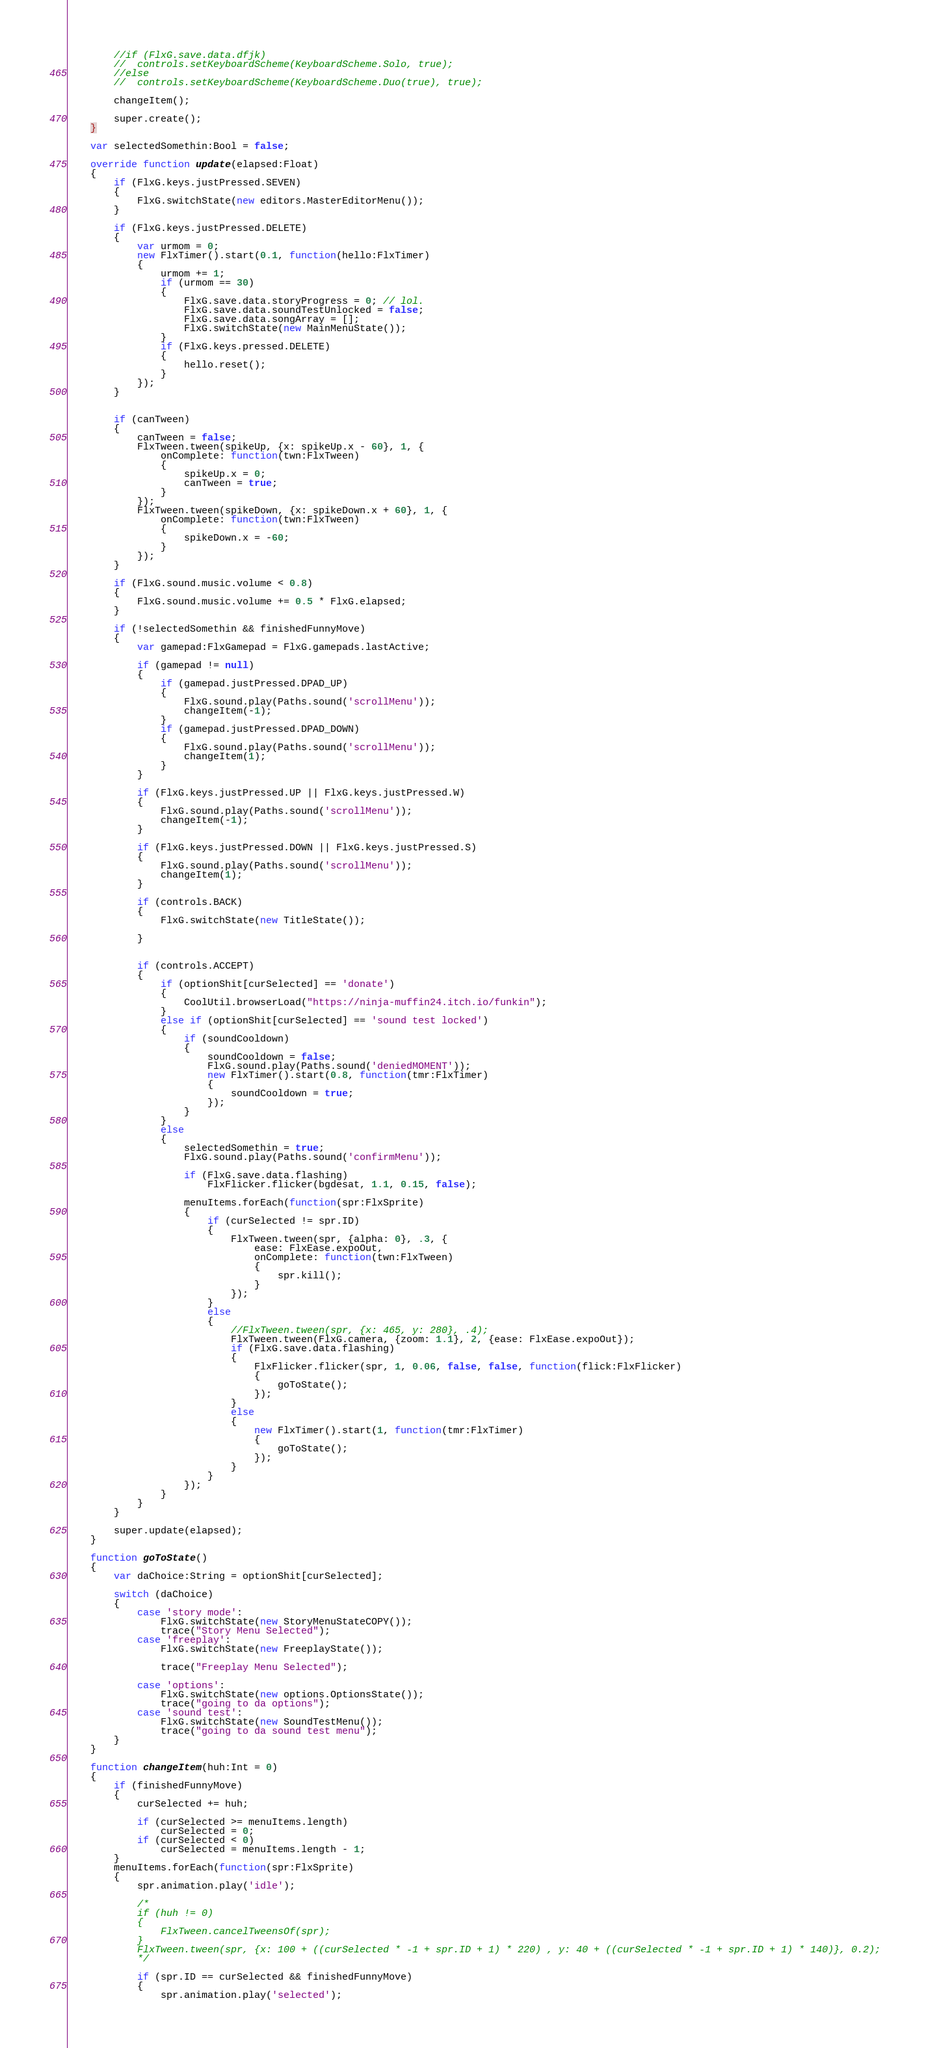Convert code to text. <code><loc_0><loc_0><loc_500><loc_500><_Haxe_>
		//if (FlxG.save.data.dfjk)
		//	controls.setKeyboardScheme(KeyboardScheme.Solo, true);
		//else
		//	controls.setKeyboardScheme(KeyboardScheme.Duo(true), true);

		changeItem();

		super.create();
	}

	var selectedSomethin:Bool = false;

	override function update(elapsed:Float)
	{
		if (FlxG.keys.justPressed.SEVEN)
		{
			FlxG.switchState(new editors.MasterEditorMenu());
		}

		if (FlxG.keys.justPressed.DELETE)
		{
			var urmom = 0;
			new FlxTimer().start(0.1, function(hello:FlxTimer)
			{
				urmom += 1;
				if (urmom == 30)
				{
					FlxG.save.data.storyProgress = 0; // lol.
					FlxG.save.data.soundTestUnlocked = false;
					FlxG.save.data.songArray = [];
					FlxG.switchState(new MainMenuState());
				}
				if (FlxG.keys.pressed.DELETE)
				{
					hello.reset();
				}
			});
		}


		if (canTween)
		{
			canTween = false;
			FlxTween.tween(spikeUp, {x: spikeUp.x - 60}, 1, {
				onComplete: function(twn:FlxTween)
				{
					spikeUp.x = 0;
					canTween = true;
				}
			});
			FlxTween.tween(spikeDown, {x: spikeDown.x + 60}, 1, {
				onComplete: function(twn:FlxTween)
				{
					spikeDown.x = -60;
				}
			});
		}

		if (FlxG.sound.music.volume < 0.8)
		{
			FlxG.sound.music.volume += 0.5 * FlxG.elapsed;
		}

		if (!selectedSomethin && finishedFunnyMove)
		{
			var gamepad:FlxGamepad = FlxG.gamepads.lastActive;

			if (gamepad != null)
			{
				if (gamepad.justPressed.DPAD_UP)
				{
					FlxG.sound.play(Paths.sound('scrollMenu'));
					changeItem(-1);
				}
				if (gamepad.justPressed.DPAD_DOWN)
				{
					FlxG.sound.play(Paths.sound('scrollMenu'));
					changeItem(1);
				}
			}

			if (FlxG.keys.justPressed.UP || FlxG.keys.justPressed.W)
			{
				FlxG.sound.play(Paths.sound('scrollMenu'));
				changeItem(-1);
			}

			if (FlxG.keys.justPressed.DOWN || FlxG.keys.justPressed.S)
			{
				FlxG.sound.play(Paths.sound('scrollMenu'));
				changeItem(1);
			}

			if (controls.BACK)
			{
				FlxG.switchState(new TitleState());

			}


			if (controls.ACCEPT)
			{
				if (optionShit[curSelected] == 'donate')
				{
					CoolUtil.browserLoad("https://ninja-muffin24.itch.io/funkin");
				}
				else if (optionShit[curSelected] == 'sound test locked')
				{
					if (soundCooldown)
					{
						soundCooldown = false;
						FlxG.sound.play(Paths.sound('deniedMOMENT'));
						new FlxTimer().start(0.8, function(tmr:FlxTimer)
						{
							soundCooldown = true;
						});
					}
				}
				else
				{
					selectedSomethin = true;
					FlxG.sound.play(Paths.sound('confirmMenu'));
					
					if (FlxG.save.data.flashing)
						FlxFlicker.flicker(bgdesat, 1.1, 0.15, false);

					menuItems.forEach(function(spr:FlxSprite)
					{
						if (curSelected != spr.ID)
						{
							FlxTween.tween(spr, {alpha: 0}, .3, {
								ease: FlxEase.expoOut,
								onComplete: function(twn:FlxTween)
								{
									spr.kill();
								}
							});
						}
						else
						{
							//FlxTween.tween(spr, {x: 465, y: 280}, .4);
							FlxTween.tween(FlxG.camera, {zoom: 1.1}, 2, {ease: FlxEase.expoOut});
							if (FlxG.save.data.flashing)
							{
								FlxFlicker.flicker(spr, 1, 0.06, false, false, function(flick:FlxFlicker)
								{
									goToState();
								});	
							}
							else
							{
								new FlxTimer().start(1, function(tmr:FlxTimer)
								{
									goToState();
								});
							}
						}
					});
				}
			}
		}

		super.update(elapsed);
	}
	
	function goToState()
	{
		var daChoice:String = optionShit[curSelected];

		switch (daChoice)
		{
			case 'story mode':
				FlxG.switchState(new StoryMenuStateCOPY());
				trace("Story Menu Selected");
			case 'freeplay':
				FlxG.switchState(new FreeplayState());

				trace("Freeplay Menu Selected");

			case 'options':
				FlxG.switchState(new options.OptionsState());
				trace("going to da options");
			case 'sound test':
				FlxG.switchState(new SoundTestMenu());
				trace("going to da sound test menu");
		}
	}

	function changeItem(huh:Int = 0)
	{
		if (finishedFunnyMove)
		{
			curSelected += huh;

			if (curSelected >= menuItems.length)
				curSelected = 0;
			if (curSelected < 0)
				curSelected = menuItems.length - 1;
		}
		menuItems.forEach(function(spr:FlxSprite)
		{
			spr.animation.play('idle');

			/*
			if (huh != 0) 
			{
				FlxTween.cancelTweensOf(spr);
			}
			FlxTween.tween(spr, {x: 100 + ((curSelected * -1 + spr.ID + 1) * 220) , y: 40 + ((curSelected * -1 + spr.ID + 1) * 140)}, 0.2);
			*/

			if (spr.ID == curSelected && finishedFunnyMove)
			{
				spr.animation.play('selected');</code> 